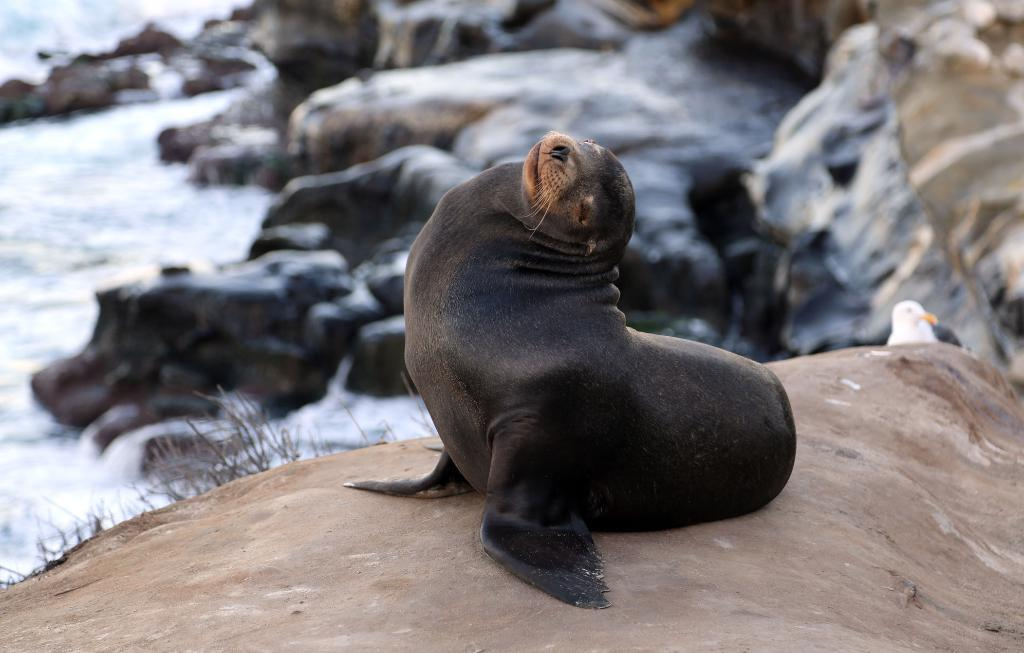What type of animal is in the image? There is a penguin in the image. What can be seen in the background of the image? There are rocks and water visible in the background of the image. What type of fruit is the penguin holding in the image? There is no fruit present in the image, and the penguin is not holding anything. 